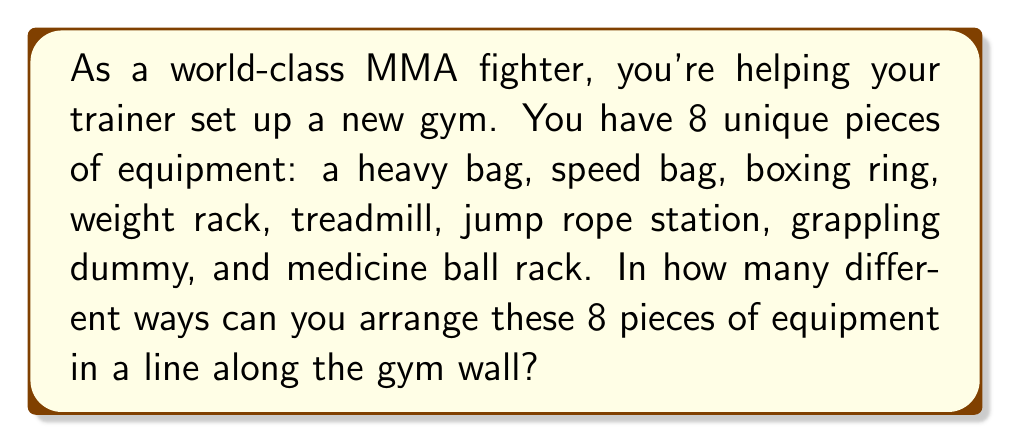Show me your answer to this math problem. Let's approach this step-by-step:

1) This is a permutation problem. We need to arrange 8 distinct objects in a line.

2) For the first position, we have 8 choices of equipment.

3) After placing the first piece, we have 7 choices for the second position.

4) For the third position, we have 6 choices, and so on.

5) This continues until we place the last piece of equipment, for which we have only 1 choice.

6) The total number of arrangements is the product of all these choices:

   $$8 \times 7 \times 6 \times 5 \times 4 \times 3 \times 2 \times 1$$

7) This is the definition of 8 factorial, written as $8!$

8) We can calculate this:
   $$8! = 8 \times 7 \times 6 \times 5 \times 4 \times 3 \times 2 \times 1 = 40,320$$

Therefore, there are 40,320 different ways to arrange the 8 pieces of equipment.
Answer: $40,320$ 